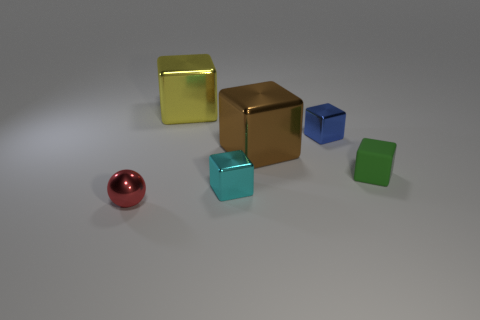What color is the shiny block that is to the right of the large shiny block right of the large yellow thing?
Offer a very short reply. Blue. There is a metal object that is to the left of the big yellow metallic cube behind the tiny shiny cube behind the cyan shiny cube; how big is it?
Offer a terse response. Small. Is the number of green matte cubes that are behind the large brown object less than the number of small red things that are behind the tiny red metallic sphere?
Give a very brief answer. No. How many large yellow objects have the same material as the green cube?
Offer a terse response. 0. There is a big metal cube that is behind the large cube that is in front of the yellow metal thing; are there any yellow cubes that are in front of it?
Ensure brevity in your answer.  No. What shape is the big yellow thing that is the same material as the blue object?
Offer a very short reply. Cube. Are there more yellow metallic things than tiny yellow balls?
Give a very brief answer. Yes. Do the yellow metal thing and the small shiny object behind the brown shiny cube have the same shape?
Offer a terse response. Yes. What is the material of the red ball?
Your answer should be very brief. Metal. The large metallic block on the right side of the large yellow metal thing that is behind the small green rubber thing that is behind the cyan metal object is what color?
Your response must be concise. Brown. 